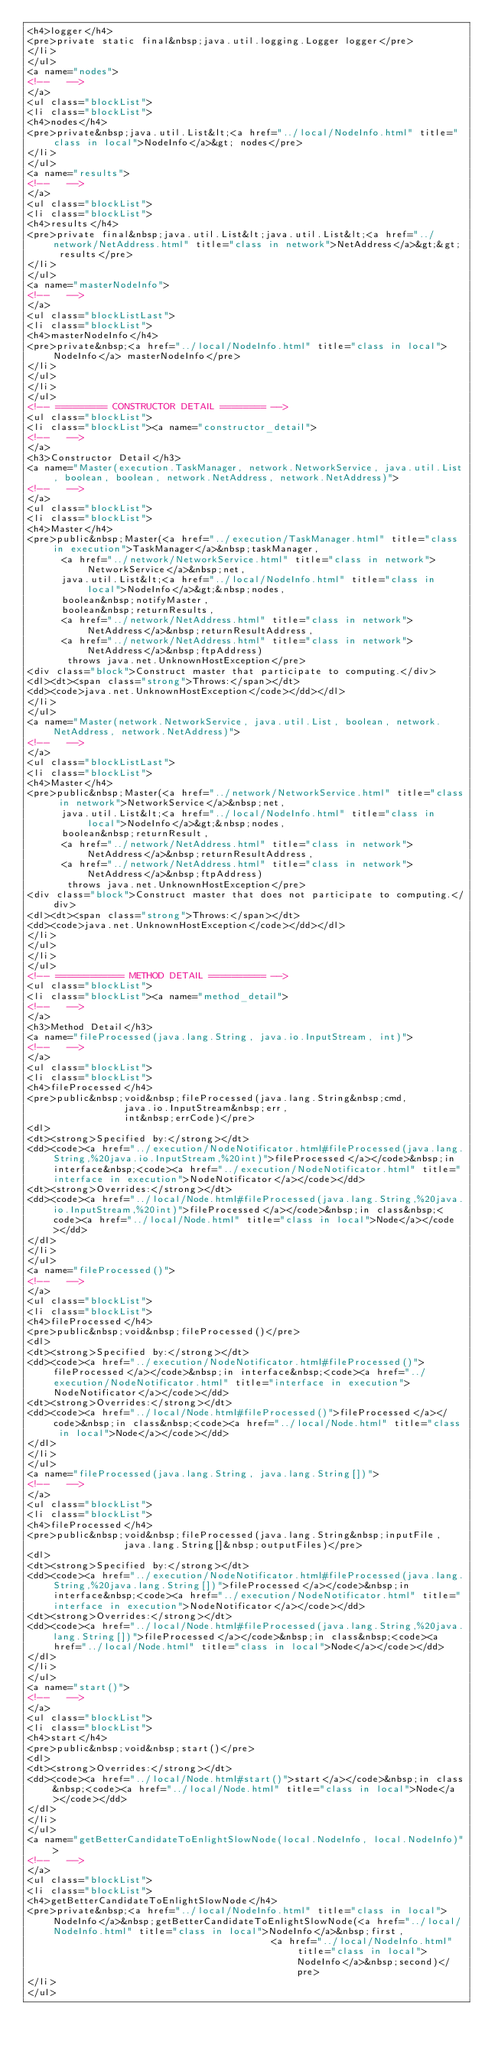Convert code to text. <code><loc_0><loc_0><loc_500><loc_500><_HTML_><h4>logger</h4>
<pre>private static final&nbsp;java.util.logging.Logger logger</pre>
</li>
</ul>
<a name="nodes">
<!--   -->
</a>
<ul class="blockList">
<li class="blockList">
<h4>nodes</h4>
<pre>private&nbsp;java.util.List&lt;<a href="../local/NodeInfo.html" title="class in local">NodeInfo</a>&gt; nodes</pre>
</li>
</ul>
<a name="results">
<!--   -->
</a>
<ul class="blockList">
<li class="blockList">
<h4>results</h4>
<pre>private final&nbsp;java.util.List&lt;java.util.List&lt;<a href="../network/NetAddress.html" title="class in network">NetAddress</a>&gt;&gt; results</pre>
</li>
</ul>
<a name="masterNodeInfo">
<!--   -->
</a>
<ul class="blockListLast">
<li class="blockList">
<h4>masterNodeInfo</h4>
<pre>private&nbsp;<a href="../local/NodeInfo.html" title="class in local">NodeInfo</a> masterNodeInfo</pre>
</li>
</ul>
</li>
</ul>
<!-- ========= CONSTRUCTOR DETAIL ======== -->
<ul class="blockList">
<li class="blockList"><a name="constructor_detail">
<!--   -->
</a>
<h3>Constructor Detail</h3>
<a name="Master(execution.TaskManager, network.NetworkService, java.util.List, boolean, boolean, network.NetAddress, network.NetAddress)">
<!--   -->
</a>
<ul class="blockList">
<li class="blockList">
<h4>Master</h4>
<pre>public&nbsp;Master(<a href="../execution/TaskManager.html" title="class in execution">TaskManager</a>&nbsp;taskManager,
      <a href="../network/NetworkService.html" title="class in network">NetworkService</a>&nbsp;net,
      java.util.List&lt;<a href="../local/NodeInfo.html" title="class in local">NodeInfo</a>&gt;&nbsp;nodes,
      boolean&nbsp;notifyMaster,
      boolean&nbsp;returnResults,
      <a href="../network/NetAddress.html" title="class in network">NetAddress</a>&nbsp;returnResultAddress,
      <a href="../network/NetAddress.html" title="class in network">NetAddress</a>&nbsp;ftpAddress)
       throws java.net.UnknownHostException</pre>
<div class="block">Construct master that participate to computing.</div>
<dl><dt><span class="strong">Throws:</span></dt>
<dd><code>java.net.UnknownHostException</code></dd></dl>
</li>
</ul>
<a name="Master(network.NetworkService, java.util.List, boolean, network.NetAddress, network.NetAddress)">
<!--   -->
</a>
<ul class="blockListLast">
<li class="blockList">
<h4>Master</h4>
<pre>public&nbsp;Master(<a href="../network/NetworkService.html" title="class in network">NetworkService</a>&nbsp;net,
      java.util.List&lt;<a href="../local/NodeInfo.html" title="class in local">NodeInfo</a>&gt;&nbsp;nodes,
      boolean&nbsp;returnResult,
      <a href="../network/NetAddress.html" title="class in network">NetAddress</a>&nbsp;returnResultAddress,
      <a href="../network/NetAddress.html" title="class in network">NetAddress</a>&nbsp;ftpAddress)
       throws java.net.UnknownHostException</pre>
<div class="block">Construct master that does not participate to computing.</div>
<dl><dt><span class="strong">Throws:</span></dt>
<dd><code>java.net.UnknownHostException</code></dd></dl>
</li>
</ul>
</li>
</ul>
<!-- ============ METHOD DETAIL ========== -->
<ul class="blockList">
<li class="blockList"><a name="method_detail">
<!--   -->
</a>
<h3>Method Detail</h3>
<a name="fileProcessed(java.lang.String, java.io.InputStream, int)">
<!--   -->
</a>
<ul class="blockList">
<li class="blockList">
<h4>fileProcessed</h4>
<pre>public&nbsp;void&nbsp;fileProcessed(java.lang.String&nbsp;cmd,
                 java.io.InputStream&nbsp;err,
                 int&nbsp;errCode)</pre>
<dl>
<dt><strong>Specified by:</strong></dt>
<dd><code><a href="../execution/NodeNotificator.html#fileProcessed(java.lang.String,%20java.io.InputStream,%20int)">fileProcessed</a></code>&nbsp;in interface&nbsp;<code><a href="../execution/NodeNotificator.html" title="interface in execution">NodeNotificator</a></code></dd>
<dt><strong>Overrides:</strong></dt>
<dd><code><a href="../local/Node.html#fileProcessed(java.lang.String,%20java.io.InputStream,%20int)">fileProcessed</a></code>&nbsp;in class&nbsp;<code><a href="../local/Node.html" title="class in local">Node</a></code></dd>
</dl>
</li>
</ul>
<a name="fileProcessed()">
<!--   -->
</a>
<ul class="blockList">
<li class="blockList">
<h4>fileProcessed</h4>
<pre>public&nbsp;void&nbsp;fileProcessed()</pre>
<dl>
<dt><strong>Specified by:</strong></dt>
<dd><code><a href="../execution/NodeNotificator.html#fileProcessed()">fileProcessed</a></code>&nbsp;in interface&nbsp;<code><a href="../execution/NodeNotificator.html" title="interface in execution">NodeNotificator</a></code></dd>
<dt><strong>Overrides:</strong></dt>
<dd><code><a href="../local/Node.html#fileProcessed()">fileProcessed</a></code>&nbsp;in class&nbsp;<code><a href="../local/Node.html" title="class in local">Node</a></code></dd>
</dl>
</li>
</ul>
<a name="fileProcessed(java.lang.String, java.lang.String[])">
<!--   -->
</a>
<ul class="blockList">
<li class="blockList">
<h4>fileProcessed</h4>
<pre>public&nbsp;void&nbsp;fileProcessed(java.lang.String&nbsp;inputFile,
                 java.lang.String[]&nbsp;outputFiles)</pre>
<dl>
<dt><strong>Specified by:</strong></dt>
<dd><code><a href="../execution/NodeNotificator.html#fileProcessed(java.lang.String,%20java.lang.String[])">fileProcessed</a></code>&nbsp;in interface&nbsp;<code><a href="../execution/NodeNotificator.html" title="interface in execution">NodeNotificator</a></code></dd>
<dt><strong>Overrides:</strong></dt>
<dd><code><a href="../local/Node.html#fileProcessed(java.lang.String,%20java.lang.String[])">fileProcessed</a></code>&nbsp;in class&nbsp;<code><a href="../local/Node.html" title="class in local">Node</a></code></dd>
</dl>
</li>
</ul>
<a name="start()">
<!--   -->
</a>
<ul class="blockList">
<li class="blockList">
<h4>start</h4>
<pre>public&nbsp;void&nbsp;start()</pre>
<dl>
<dt><strong>Overrides:</strong></dt>
<dd><code><a href="../local/Node.html#start()">start</a></code>&nbsp;in class&nbsp;<code><a href="../local/Node.html" title="class in local">Node</a></code></dd>
</dl>
</li>
</ul>
<a name="getBetterCandidateToEnlightSlowNode(local.NodeInfo, local.NodeInfo)">
<!--   -->
</a>
<ul class="blockList">
<li class="blockList">
<h4>getBetterCandidateToEnlightSlowNode</h4>
<pre>private&nbsp;<a href="../local/NodeInfo.html" title="class in local">NodeInfo</a>&nbsp;getBetterCandidateToEnlightSlowNode(<a href="../local/NodeInfo.html" title="class in local">NodeInfo</a>&nbsp;first,
                                           <a href="../local/NodeInfo.html" title="class in local">NodeInfo</a>&nbsp;second)</pre>
</li>
</ul></code> 